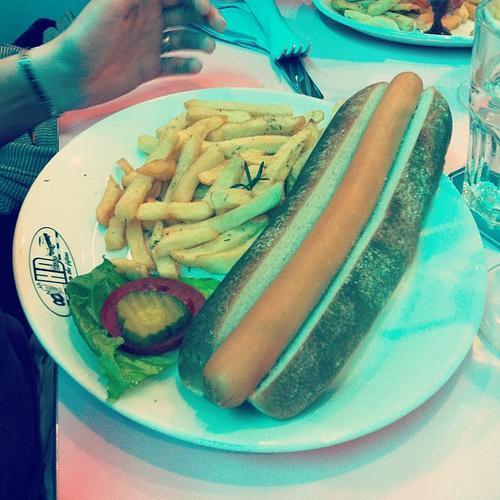How many hotdogs on plate?
Give a very brief answer. 1. How many pieces of silverware are shown?
Give a very brief answer. 2. 